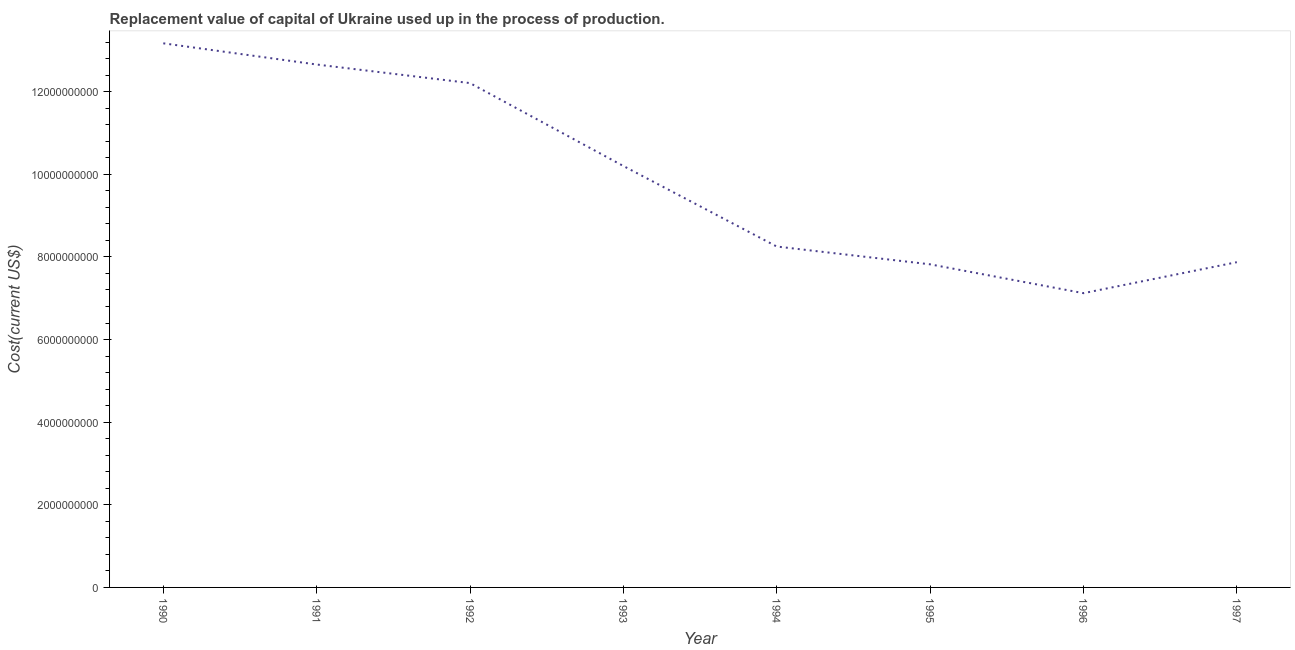What is the consumption of fixed capital in 1992?
Keep it short and to the point. 1.22e+1. Across all years, what is the maximum consumption of fixed capital?
Your response must be concise. 1.32e+1. Across all years, what is the minimum consumption of fixed capital?
Your answer should be compact. 7.12e+09. In which year was the consumption of fixed capital maximum?
Your response must be concise. 1990. What is the sum of the consumption of fixed capital?
Give a very brief answer. 7.93e+1. What is the difference between the consumption of fixed capital in 1990 and 1995?
Give a very brief answer. 5.35e+09. What is the average consumption of fixed capital per year?
Offer a terse response. 9.91e+09. What is the median consumption of fixed capital?
Make the answer very short. 9.23e+09. Do a majority of the years between 1990 and 1997 (inclusive) have consumption of fixed capital greater than 6400000000 US$?
Your answer should be compact. Yes. What is the ratio of the consumption of fixed capital in 1991 to that in 1995?
Provide a succinct answer. 1.62. Is the consumption of fixed capital in 1991 less than that in 1993?
Make the answer very short. No. What is the difference between the highest and the second highest consumption of fixed capital?
Keep it short and to the point. 5.13e+08. What is the difference between the highest and the lowest consumption of fixed capital?
Your response must be concise. 6.05e+09. In how many years, is the consumption of fixed capital greater than the average consumption of fixed capital taken over all years?
Keep it short and to the point. 4. How many lines are there?
Your answer should be very brief. 1. How many years are there in the graph?
Offer a terse response. 8. Are the values on the major ticks of Y-axis written in scientific E-notation?
Provide a short and direct response. No. Does the graph contain grids?
Give a very brief answer. No. What is the title of the graph?
Keep it short and to the point. Replacement value of capital of Ukraine used up in the process of production. What is the label or title of the X-axis?
Keep it short and to the point. Year. What is the label or title of the Y-axis?
Keep it short and to the point. Cost(current US$). What is the Cost(current US$) in 1990?
Ensure brevity in your answer.  1.32e+1. What is the Cost(current US$) of 1991?
Make the answer very short. 1.27e+1. What is the Cost(current US$) in 1992?
Provide a short and direct response. 1.22e+1. What is the Cost(current US$) in 1993?
Offer a very short reply. 1.02e+1. What is the Cost(current US$) of 1994?
Ensure brevity in your answer.  8.25e+09. What is the Cost(current US$) of 1995?
Provide a short and direct response. 7.82e+09. What is the Cost(current US$) of 1996?
Keep it short and to the point. 7.12e+09. What is the Cost(current US$) of 1997?
Your response must be concise. 7.87e+09. What is the difference between the Cost(current US$) in 1990 and 1991?
Provide a short and direct response. 5.13e+08. What is the difference between the Cost(current US$) in 1990 and 1992?
Provide a succinct answer. 9.63e+08. What is the difference between the Cost(current US$) in 1990 and 1993?
Keep it short and to the point. 2.97e+09. What is the difference between the Cost(current US$) in 1990 and 1994?
Offer a very short reply. 4.92e+09. What is the difference between the Cost(current US$) in 1990 and 1995?
Give a very brief answer. 5.35e+09. What is the difference between the Cost(current US$) in 1990 and 1996?
Provide a short and direct response. 6.05e+09. What is the difference between the Cost(current US$) in 1990 and 1997?
Offer a terse response. 5.30e+09. What is the difference between the Cost(current US$) in 1991 and 1992?
Provide a short and direct response. 4.50e+08. What is the difference between the Cost(current US$) in 1991 and 1993?
Keep it short and to the point. 2.46e+09. What is the difference between the Cost(current US$) in 1991 and 1994?
Your response must be concise. 4.41e+09. What is the difference between the Cost(current US$) in 1991 and 1995?
Give a very brief answer. 4.84e+09. What is the difference between the Cost(current US$) in 1991 and 1996?
Provide a short and direct response. 5.54e+09. What is the difference between the Cost(current US$) in 1991 and 1997?
Ensure brevity in your answer.  4.79e+09. What is the difference between the Cost(current US$) in 1992 and 1993?
Keep it short and to the point. 2.01e+09. What is the difference between the Cost(current US$) in 1992 and 1994?
Keep it short and to the point. 3.96e+09. What is the difference between the Cost(current US$) in 1992 and 1995?
Keep it short and to the point. 4.39e+09. What is the difference between the Cost(current US$) in 1992 and 1996?
Provide a short and direct response. 5.09e+09. What is the difference between the Cost(current US$) in 1992 and 1997?
Your answer should be very brief. 4.34e+09. What is the difference between the Cost(current US$) in 1993 and 1994?
Offer a terse response. 1.95e+09. What is the difference between the Cost(current US$) in 1993 and 1995?
Provide a succinct answer. 2.38e+09. What is the difference between the Cost(current US$) in 1993 and 1996?
Provide a succinct answer. 3.08e+09. What is the difference between the Cost(current US$) in 1993 and 1997?
Give a very brief answer. 2.33e+09. What is the difference between the Cost(current US$) in 1994 and 1995?
Your response must be concise. 4.31e+08. What is the difference between the Cost(current US$) in 1994 and 1996?
Provide a succinct answer. 1.13e+09. What is the difference between the Cost(current US$) in 1994 and 1997?
Offer a very short reply. 3.79e+08. What is the difference between the Cost(current US$) in 1995 and 1996?
Provide a succinct answer. 6.98e+08. What is the difference between the Cost(current US$) in 1995 and 1997?
Keep it short and to the point. -5.16e+07. What is the difference between the Cost(current US$) in 1996 and 1997?
Make the answer very short. -7.50e+08. What is the ratio of the Cost(current US$) in 1990 to that in 1991?
Keep it short and to the point. 1.04. What is the ratio of the Cost(current US$) in 1990 to that in 1992?
Provide a succinct answer. 1.08. What is the ratio of the Cost(current US$) in 1990 to that in 1993?
Give a very brief answer. 1.29. What is the ratio of the Cost(current US$) in 1990 to that in 1994?
Make the answer very short. 1.6. What is the ratio of the Cost(current US$) in 1990 to that in 1995?
Make the answer very short. 1.68. What is the ratio of the Cost(current US$) in 1990 to that in 1996?
Your response must be concise. 1.85. What is the ratio of the Cost(current US$) in 1990 to that in 1997?
Your response must be concise. 1.67. What is the ratio of the Cost(current US$) in 1991 to that in 1992?
Give a very brief answer. 1.04. What is the ratio of the Cost(current US$) in 1991 to that in 1993?
Your response must be concise. 1.24. What is the ratio of the Cost(current US$) in 1991 to that in 1994?
Provide a short and direct response. 1.53. What is the ratio of the Cost(current US$) in 1991 to that in 1995?
Your answer should be compact. 1.62. What is the ratio of the Cost(current US$) in 1991 to that in 1996?
Make the answer very short. 1.78. What is the ratio of the Cost(current US$) in 1991 to that in 1997?
Give a very brief answer. 1.61. What is the ratio of the Cost(current US$) in 1992 to that in 1993?
Provide a short and direct response. 1.2. What is the ratio of the Cost(current US$) in 1992 to that in 1994?
Provide a short and direct response. 1.48. What is the ratio of the Cost(current US$) in 1992 to that in 1995?
Offer a very short reply. 1.56. What is the ratio of the Cost(current US$) in 1992 to that in 1996?
Your answer should be very brief. 1.71. What is the ratio of the Cost(current US$) in 1992 to that in 1997?
Give a very brief answer. 1.55. What is the ratio of the Cost(current US$) in 1993 to that in 1994?
Keep it short and to the point. 1.24. What is the ratio of the Cost(current US$) in 1993 to that in 1995?
Offer a very short reply. 1.3. What is the ratio of the Cost(current US$) in 1993 to that in 1996?
Offer a terse response. 1.43. What is the ratio of the Cost(current US$) in 1993 to that in 1997?
Your answer should be very brief. 1.3. What is the ratio of the Cost(current US$) in 1994 to that in 1995?
Your answer should be very brief. 1.05. What is the ratio of the Cost(current US$) in 1994 to that in 1996?
Provide a succinct answer. 1.16. What is the ratio of the Cost(current US$) in 1994 to that in 1997?
Make the answer very short. 1.05. What is the ratio of the Cost(current US$) in 1995 to that in 1996?
Provide a succinct answer. 1.1. What is the ratio of the Cost(current US$) in 1996 to that in 1997?
Your answer should be very brief. 0.91. 